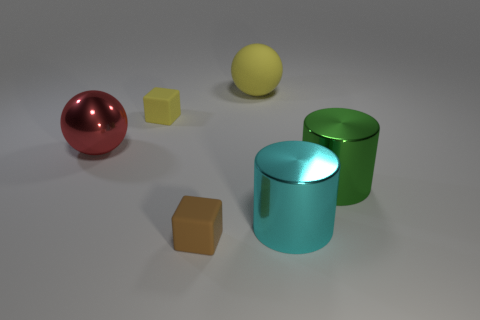Is the number of big shiny spheres greater than the number of tiny gray matte spheres?
Offer a terse response. Yes. What is the size of the red shiny object?
Your response must be concise. Large. How many other objects are there of the same color as the large shiny sphere?
Your response must be concise. 0. Is the object in front of the big cyan metallic cylinder made of the same material as the tiny yellow block?
Give a very brief answer. Yes. Is the number of tiny yellow rubber objects on the right side of the cyan object less than the number of large green shiny objects that are right of the large red shiny object?
Give a very brief answer. Yes. How many other objects are the same material as the large cyan cylinder?
Your answer should be very brief. 2. There is a yellow block that is the same size as the brown matte thing; what material is it?
Ensure brevity in your answer.  Rubber. Is the number of tiny brown objects that are in front of the big red shiny thing less than the number of tiny purple shiny spheres?
Make the answer very short. No. What shape is the green metallic object in front of the tiny thing that is behind the small rubber block that is in front of the red metallic ball?
Make the answer very short. Cylinder. How big is the cube on the left side of the tiny brown matte cube?
Offer a terse response. Small. 